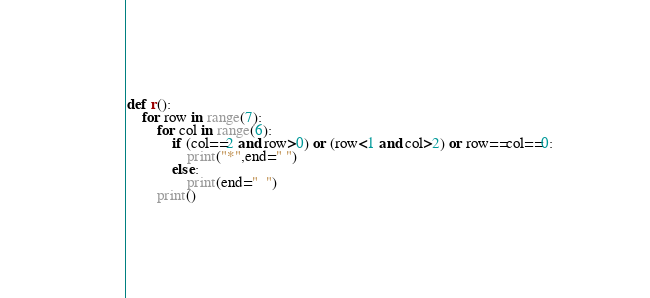<code> <loc_0><loc_0><loc_500><loc_500><_Python_>def r():
    for row in range(7):
        for col in range(6):
            if (col==2 and row>0) or (row<1 and col>2) or row==col==0:
                print("*",end=" ")
            else:
                print(end="  ")
        print()
</code> 